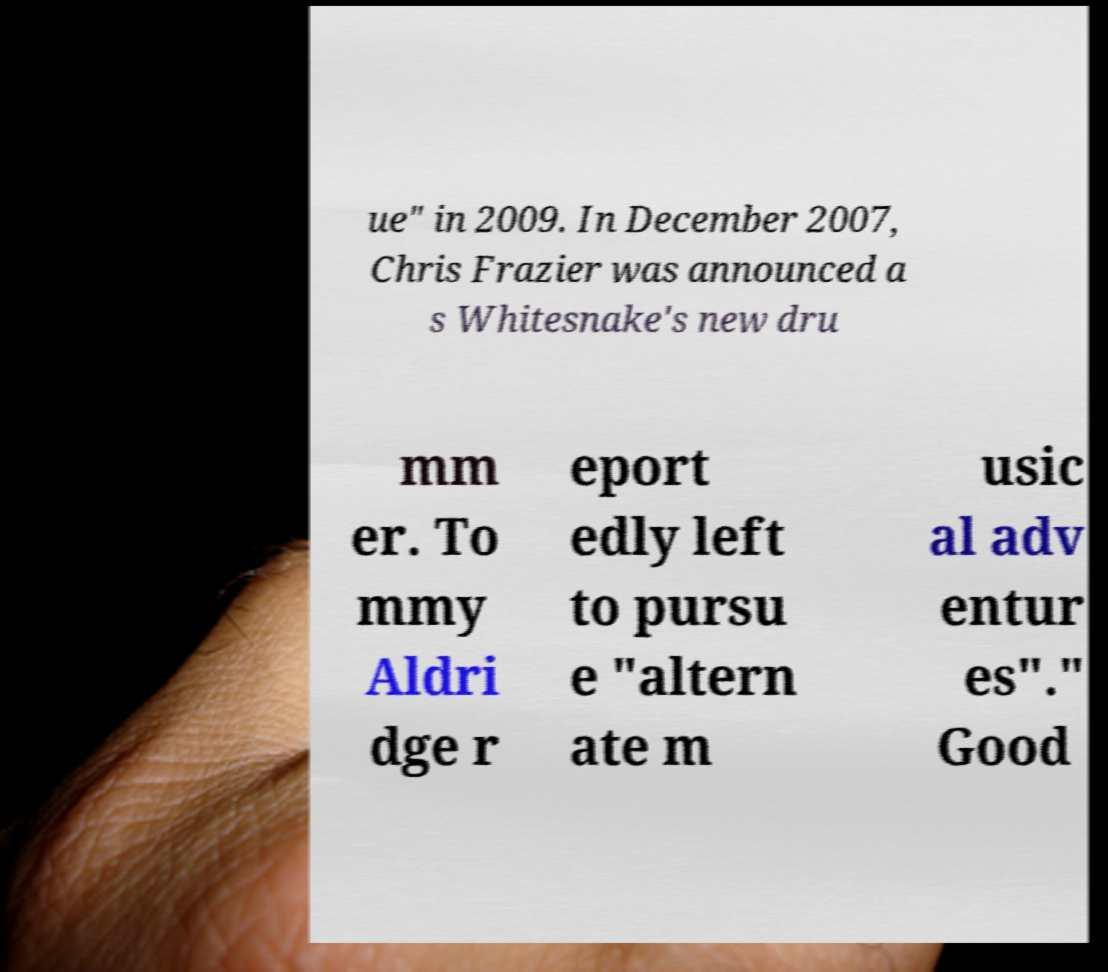There's text embedded in this image that I need extracted. Can you transcribe it verbatim? ue" in 2009. In December 2007, Chris Frazier was announced a s Whitesnake's new dru mm er. To mmy Aldri dge r eport edly left to pursu e "altern ate m usic al adv entur es"." Good 